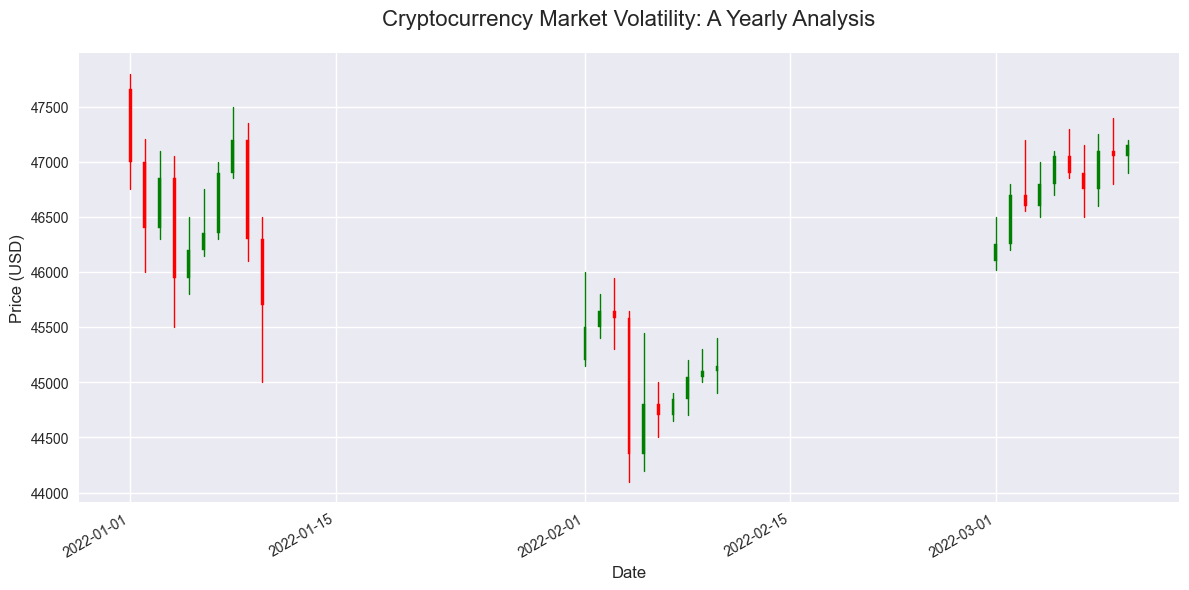What's the highest closing price among all the dates? Identify the highest closing price value from the candlestick figure by looking at the top end of the green bars (if the bar itself is not green, the top end of the body may need to be looked at individually). The date with the highest closing price will have the longest green candlestick or the highest point of the body if it ends higher than it started (green). The highest value can be found visually.
Answer: 47500.00 Compare the closing prices on January 1, 2022, and February 1, 2022, which one is higher? First, locate the candlestick representing January 1, 2022, and note its closing price which is the top of the green bar. Then, locate February 1, 2022, and note its closing price. Compare the two values; the higher value's corresponding date has the higher closing price.
Answer: January 1, 2022 What was the approximate price range (difference between high and low) on March 9, 2022? Identify the candlestick for March 9, 2022. Note down the 'High' and 'Low' values from the figure, then subtract the low value from the high value to get the price range.
Answer: 600 On which date can you find the largest trading volume? Explain your answer. Examine the volume values and identify the date with the highest volume. The height of the corresponding candlestick will be greater where the volume is highest. Look at the figure and find which candlestick is associated with the largest volume value.
Answer: January 9, 2022 What is the general trend observed in the first week of January 2022? Identify the candlesticks from January 1 to January 7, 2022. Observe the overall movement in the closing prices against the opening prices, noticing if the green bars outnumber the red bars and their predominant direction.
Answer: Downward trend What is the difference between the closing prices on January 10, 2022, and February 10, 2022? Locate the candlesticks for January 10, 2022, and February 10, 2022. Note the closing prices for each and subtract the January 10 closing price from the February 10 closing price to find the difference.
Answer: -550 Which month had overall higher closing prices, January or March? Compare the series of closing prices of January and those of March by visually measuring the heights of the green and red bars' top ends from each month, then determine which set has higher values. Summarize the overall trend for a final comparison.
Answer: March Which day in March had the maximum price fluctuation (difference between highest and lowest prices)? Identify each candlestick in March, noting the high and low prices for each day. Calculate the fluctuation by subtracting the low price from the high price. Compare the fluctuations and identify which day had the maximum.
Answer: March 3, 2022 How many days had a closing price higher than the opening price in February? Count the number of green candlesticks in February. Green bars indicate the closing price was higher than the opening price.
Answer: 5 On which specific day in February did the lowest closing price occur? Look for the shortest green bar (or the lower ends of the red bars' bodies) in February and find the closing price for the corresponding date to determine which day had the lowest value.
Answer: February 4, 2022 